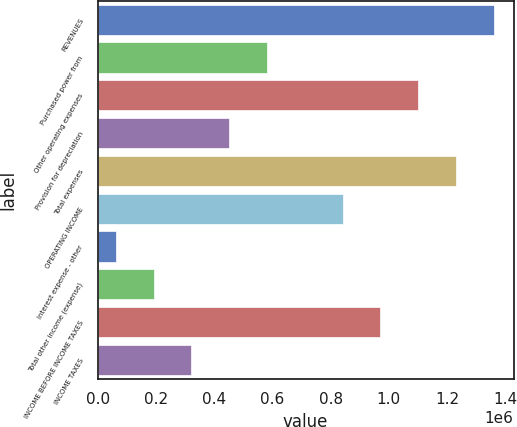Convert chart to OTSL. <chart><loc_0><loc_0><loc_500><loc_500><bar_chart><fcel>REVENUES<fcel>Purchased power from<fcel>Other operating expenses<fcel>Provision for depreciation<fcel>Total expenses<fcel>OPERATING INCOME<fcel>Interest expense - other<fcel>Total other income (expense)<fcel>INCOME BEFORE INCOME TAXES<fcel>INCOME TAXES<nl><fcel>1.36052e+06<fcel>581429<fcel>1.10082e+06<fcel>451580<fcel>1.23067e+06<fcel>841127<fcel>62034<fcel>191883<fcel>970976<fcel>321732<nl></chart> 